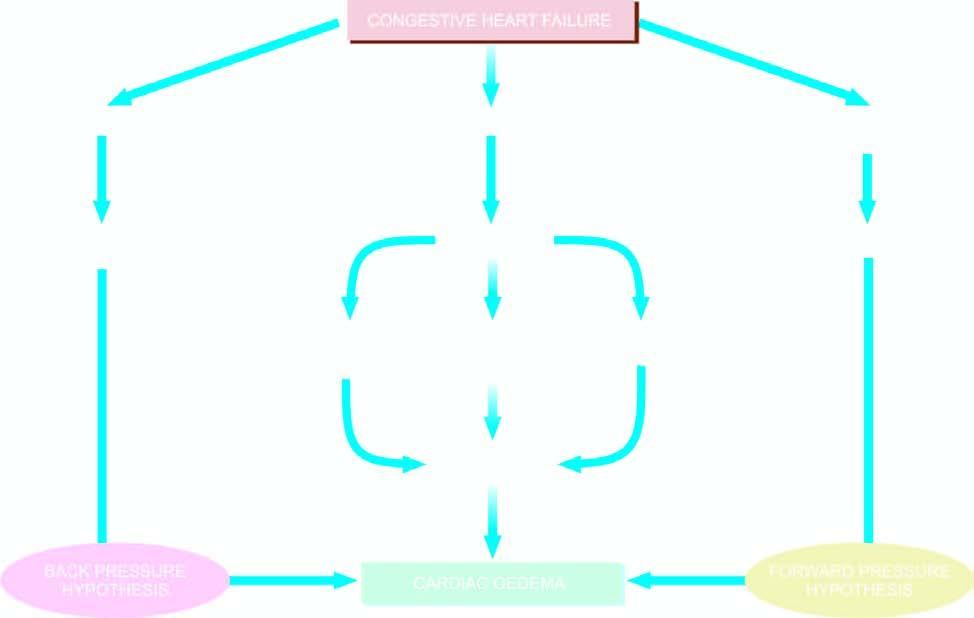what is involved in the pathogenesis of cardiac oedema?
Answer the question using a single word or phrase. Mechanisms 